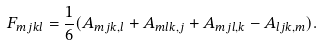Convert formula to latex. <formula><loc_0><loc_0><loc_500><loc_500>F _ { m j k l } = \frac { 1 } { 6 } ( A _ { m j k , l } + A _ { m l k , j } + A _ { m j l , k } - A _ { l j k , m } ) .</formula> 